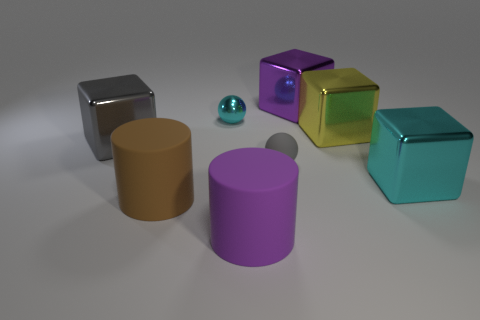Subtract all yellow cubes. How many cubes are left? 3 Add 1 tiny metallic spheres. How many objects exist? 9 Subtract all cyan balls. How many balls are left? 1 Subtract all spheres. How many objects are left? 6 Subtract 4 blocks. How many blocks are left? 0 Subtract all red cylinders. Subtract all yellow balls. How many cylinders are left? 2 Subtract all matte spheres. Subtract all small gray rubber things. How many objects are left? 6 Add 1 cubes. How many cubes are left? 5 Add 8 gray matte things. How many gray matte things exist? 9 Subtract 0 green balls. How many objects are left? 8 